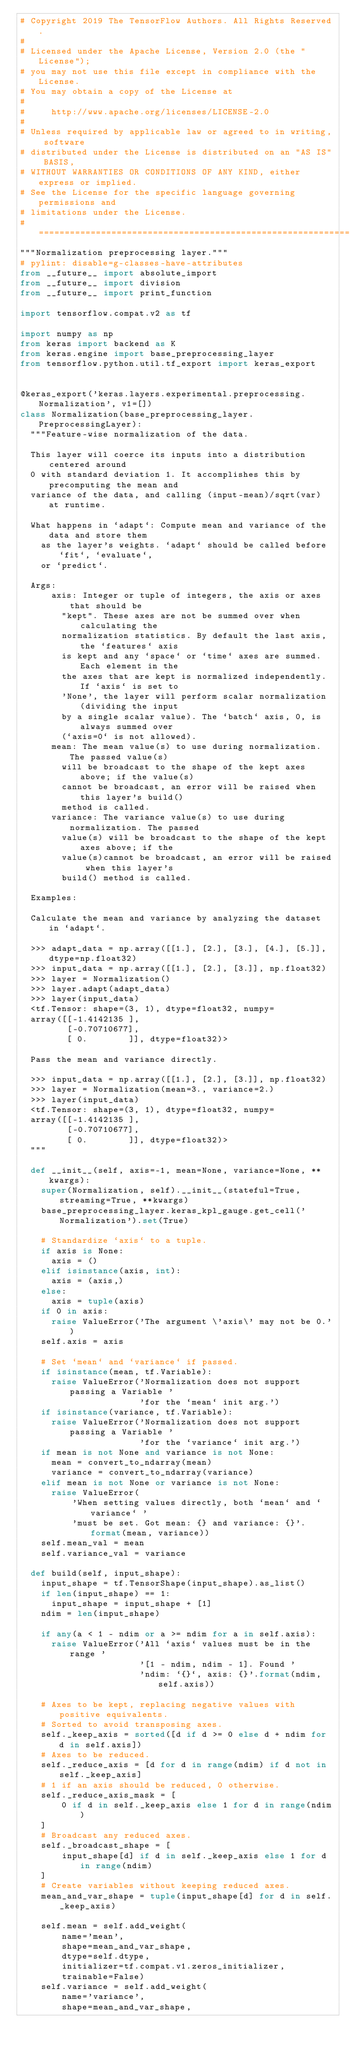<code> <loc_0><loc_0><loc_500><loc_500><_Python_># Copyright 2019 The TensorFlow Authors. All Rights Reserved.
#
# Licensed under the Apache License, Version 2.0 (the "License");
# you may not use this file except in compliance with the License.
# You may obtain a copy of the License at
#
#     http://www.apache.org/licenses/LICENSE-2.0
#
# Unless required by applicable law or agreed to in writing, software
# distributed under the License is distributed on an "AS IS" BASIS,
# WITHOUT WARRANTIES OR CONDITIONS OF ANY KIND, either express or implied.
# See the License for the specific language governing permissions and
# limitations under the License.
# ==============================================================================
"""Normalization preprocessing layer."""
# pylint: disable=g-classes-have-attributes
from __future__ import absolute_import
from __future__ import division
from __future__ import print_function

import tensorflow.compat.v2 as tf

import numpy as np
from keras import backend as K
from keras.engine import base_preprocessing_layer
from tensorflow.python.util.tf_export import keras_export


@keras_export('keras.layers.experimental.preprocessing.Normalization', v1=[])
class Normalization(base_preprocessing_layer.PreprocessingLayer):
  """Feature-wise normalization of the data.

  This layer will coerce its inputs into a distribution centered around
  0 with standard deviation 1. It accomplishes this by precomputing the mean and
  variance of the data, and calling (input-mean)/sqrt(var) at runtime.

  What happens in `adapt`: Compute mean and variance of the data and store them
    as the layer's weights. `adapt` should be called before `fit`, `evaluate`,
    or `predict`.

  Args:
      axis: Integer or tuple of integers, the axis or axes that should be
        "kept". These axes are not be summed over when calculating the
        normalization statistics. By default the last axis, the `features` axis
        is kept and any `space` or `time` axes are summed. Each element in the
        the axes that are kept is normalized independently. If `axis` is set to
        'None', the layer will perform scalar normalization (dividing the input
        by a single scalar value). The `batch` axis, 0, is always summed over
        (`axis=0` is not allowed).
      mean: The mean value(s) to use during normalization. The passed value(s)
        will be broadcast to the shape of the kept axes above; if the value(s)
        cannot be broadcast, an error will be raised when this layer's build()
        method is called.
      variance: The variance value(s) to use during normalization. The passed
        value(s) will be broadcast to the shape of the kept axes above; if the
        value(s)cannot be broadcast, an error will be raised when this layer's
        build() method is called.

  Examples:

  Calculate the mean and variance by analyzing the dataset in `adapt`.

  >>> adapt_data = np.array([[1.], [2.], [3.], [4.], [5.]], dtype=np.float32)
  >>> input_data = np.array([[1.], [2.], [3.]], np.float32)
  >>> layer = Normalization()
  >>> layer.adapt(adapt_data)
  >>> layer(input_data)
  <tf.Tensor: shape=(3, 1), dtype=float32, numpy=
  array([[-1.4142135 ],
         [-0.70710677],
         [ 0.        ]], dtype=float32)>

  Pass the mean and variance directly.

  >>> input_data = np.array([[1.], [2.], [3.]], np.float32)
  >>> layer = Normalization(mean=3., variance=2.)
  >>> layer(input_data)
  <tf.Tensor: shape=(3, 1), dtype=float32, numpy=
  array([[-1.4142135 ],
         [-0.70710677],
         [ 0.        ]], dtype=float32)>
  """

  def __init__(self, axis=-1, mean=None, variance=None, **kwargs):
    super(Normalization, self).__init__(stateful=True, streaming=True, **kwargs)
    base_preprocessing_layer.keras_kpl_gauge.get_cell('Normalization').set(True)

    # Standardize `axis` to a tuple.
    if axis is None:
      axis = ()
    elif isinstance(axis, int):
      axis = (axis,)
    else:
      axis = tuple(axis)
    if 0 in axis:
      raise ValueError('The argument \'axis\' may not be 0.')
    self.axis = axis

    # Set `mean` and `variance` if passed.
    if isinstance(mean, tf.Variable):
      raise ValueError('Normalization does not support passing a Variable '
                       'for the `mean` init arg.')
    if isinstance(variance, tf.Variable):
      raise ValueError('Normalization does not support passing a Variable '
                       'for the `variance` init arg.')
    if mean is not None and variance is not None:
      mean = convert_to_ndarray(mean)
      variance = convert_to_ndarray(variance)
    elif mean is not None or variance is not None:
      raise ValueError(
          'When setting values directly, both `mean` and `variance` '
          'must be set. Got mean: {} and variance: {}'.format(mean, variance))
    self.mean_val = mean
    self.variance_val = variance

  def build(self, input_shape):
    input_shape = tf.TensorShape(input_shape).as_list()
    if len(input_shape) == 1:
      input_shape = input_shape + [1]
    ndim = len(input_shape)

    if any(a < 1 - ndim or a >= ndim for a in self.axis):
      raise ValueError('All `axis` values must be in the range '
                       '[1 - ndim, ndim - 1]. Found '
                       'ndim: `{}`, axis: {}'.format(ndim, self.axis))

    # Axes to be kept, replacing negative values with positive equivalents.
    # Sorted to avoid transposing axes.
    self._keep_axis = sorted([d if d >= 0 else d + ndim for d in self.axis])
    # Axes to be reduced.
    self._reduce_axis = [d for d in range(ndim) if d not in self._keep_axis]
    # 1 if an axis should be reduced, 0 otherwise.
    self._reduce_axis_mask = [
        0 if d in self._keep_axis else 1 for d in range(ndim)
    ]
    # Broadcast any reduced axes.
    self._broadcast_shape = [
        input_shape[d] if d in self._keep_axis else 1 for d in range(ndim)
    ]
    # Create variables without keeping reduced axes.
    mean_and_var_shape = tuple(input_shape[d] for d in self._keep_axis)

    self.mean = self.add_weight(
        name='mean',
        shape=mean_and_var_shape,
        dtype=self.dtype,
        initializer=tf.compat.v1.zeros_initializer,
        trainable=False)
    self.variance = self.add_weight(
        name='variance',
        shape=mean_and_var_shape,</code> 